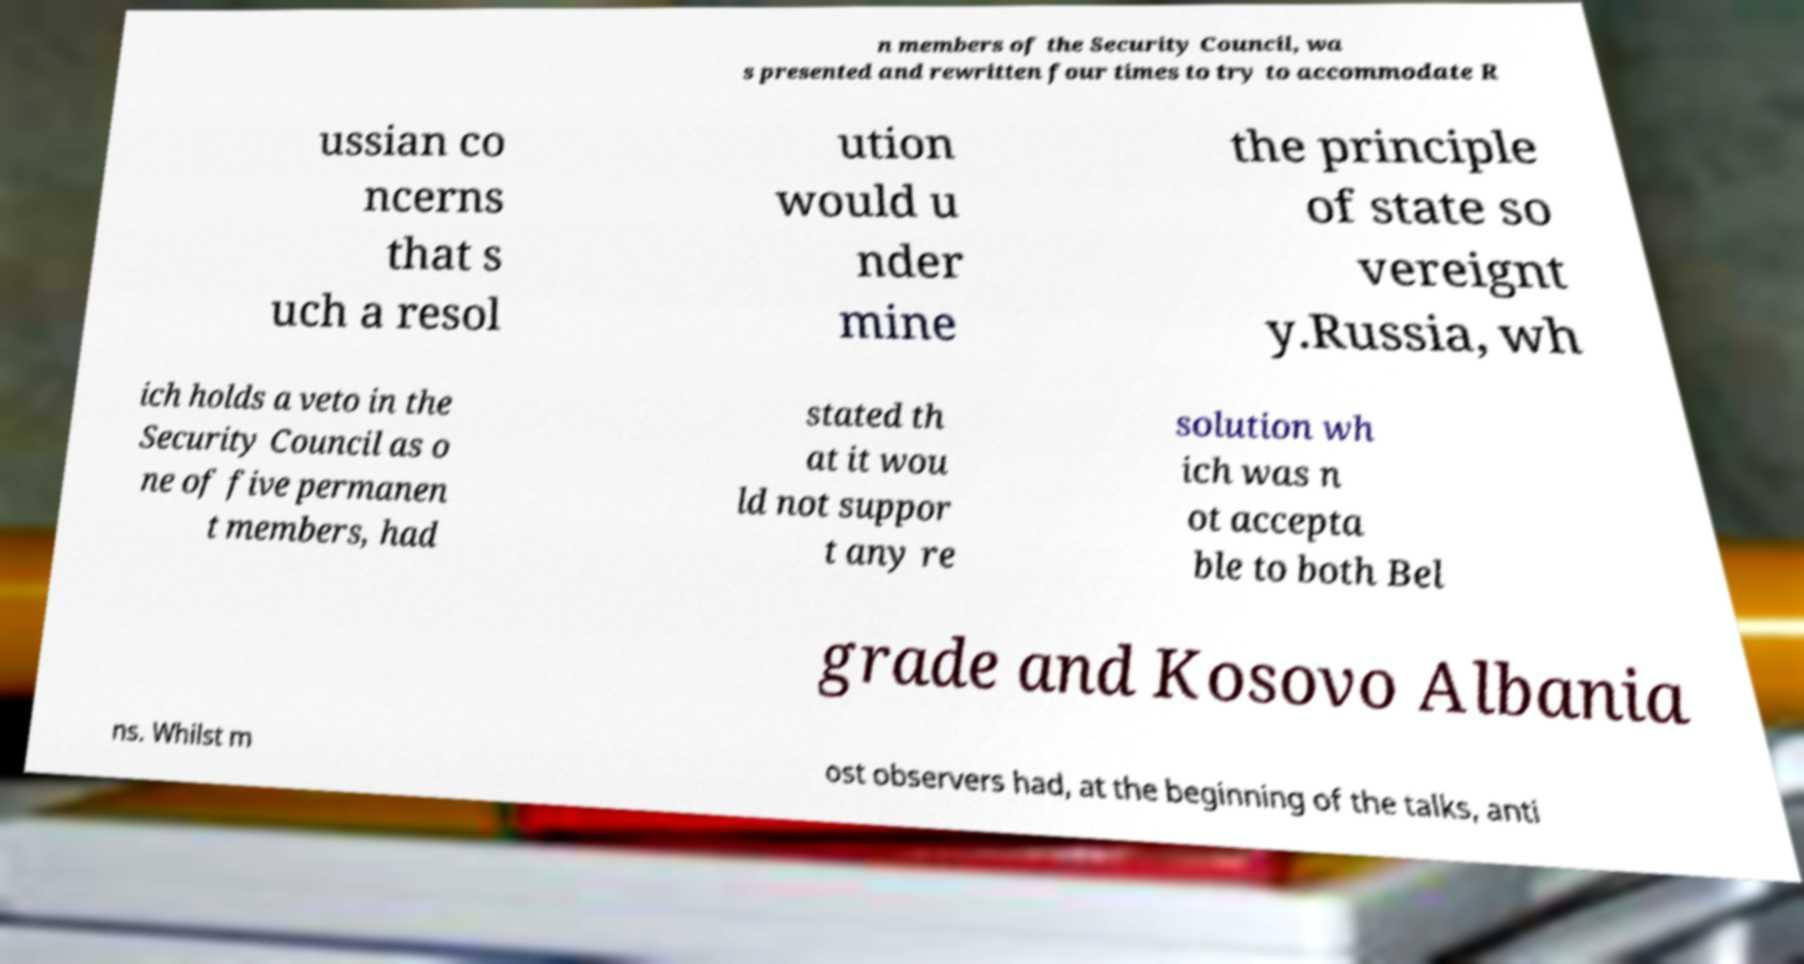Could you extract and type out the text from this image? n members of the Security Council, wa s presented and rewritten four times to try to accommodate R ussian co ncerns that s uch a resol ution would u nder mine the principle of state so vereignt y.Russia, wh ich holds a veto in the Security Council as o ne of five permanen t members, had stated th at it wou ld not suppor t any re solution wh ich was n ot accepta ble to both Bel grade and Kosovo Albania ns. Whilst m ost observers had, at the beginning of the talks, anti 